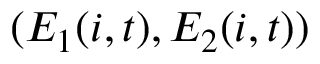Convert formula to latex. <formula><loc_0><loc_0><loc_500><loc_500>( E _ { 1 } ( i , t ) , E _ { 2 } ( i , t ) )</formula> 